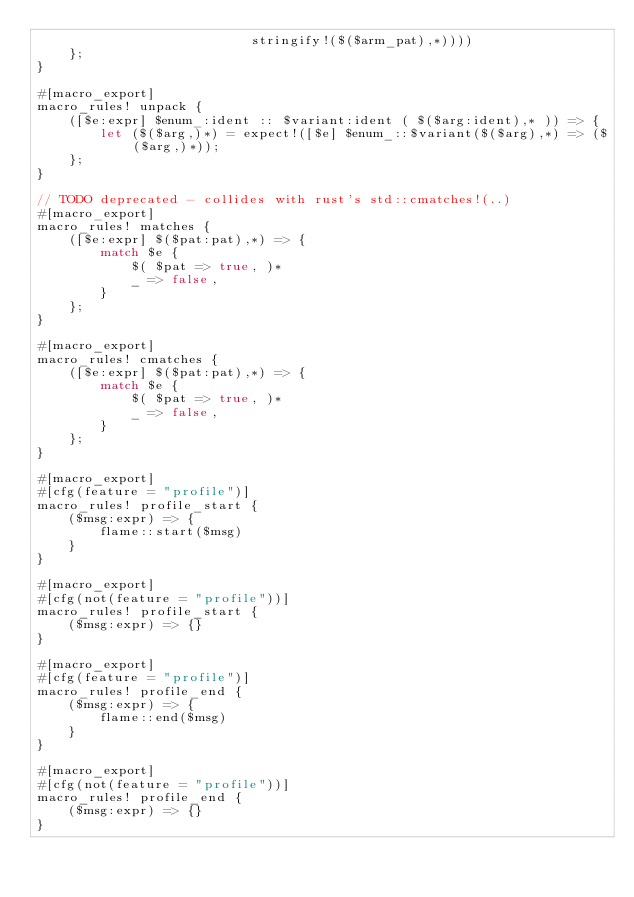Convert code to text. <code><loc_0><loc_0><loc_500><loc_500><_Rust_>                           stringify!($($arm_pat),*))))
    };
}

#[macro_export]
macro_rules! unpack {
    ([$e:expr] $enum_:ident :: $variant:ident ( $($arg:ident),* )) => {
        let ($($arg,)*) = expect!([$e] $enum_::$variant($($arg),*) => ($($arg,)*));
    };
}

// TODO deprecated - collides with rust's std::cmatches!(..)
#[macro_export]
macro_rules! matches {
    ([$e:expr] $($pat:pat),*) => {
        match $e {
            $( $pat => true, )*
            _ => false,
        }
    };
}

#[macro_export]
macro_rules! cmatches {
    ([$e:expr] $($pat:pat),*) => {
        match $e {
            $( $pat => true, )*
            _ => false,
        }
    };
}

#[macro_export]
#[cfg(feature = "profile")]
macro_rules! profile_start {
    ($msg:expr) => {
        flame::start($msg)
    }
}

#[macro_export]
#[cfg(not(feature = "profile"))]
macro_rules! profile_start {
    ($msg:expr) => {}
}

#[macro_export]
#[cfg(feature = "profile")]
macro_rules! profile_end {
    ($msg:expr) => {
        flame::end($msg)
    }
}

#[macro_export]
#[cfg(not(feature = "profile"))]
macro_rules! profile_end {
    ($msg:expr) => {}
}
</code> 